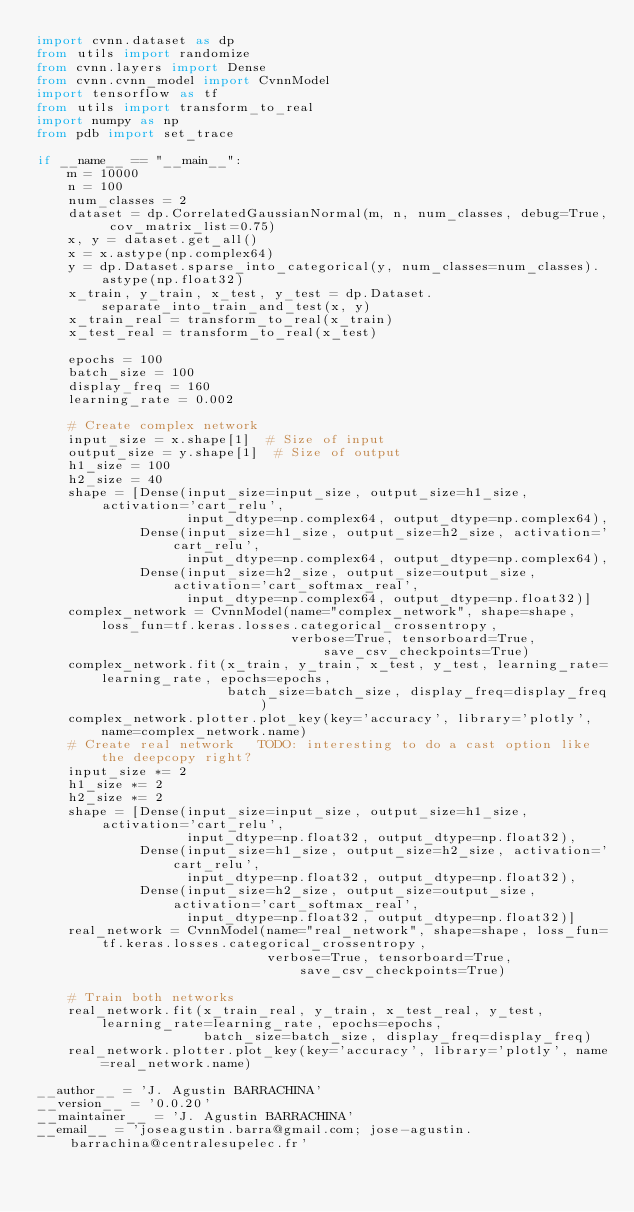Convert code to text. <code><loc_0><loc_0><loc_500><loc_500><_Python_>import cvnn.dataset as dp
from utils import randomize
from cvnn.layers import Dense
from cvnn.cvnn_model import CvnnModel
import tensorflow as tf
from utils import transform_to_real
import numpy as np
from pdb import set_trace

if __name__ == "__main__":
    m = 10000
    n = 100
    num_classes = 2
    dataset = dp.CorrelatedGaussianNormal(m, n, num_classes, debug=True, cov_matrix_list=0.75)
    x, y = dataset.get_all()
    x = x.astype(np.complex64)
    y = dp.Dataset.sparse_into_categorical(y, num_classes=num_classes).astype(np.float32)
    x_train, y_train, x_test, y_test = dp.Dataset.separate_into_train_and_test(x, y)
    x_train_real = transform_to_real(x_train)
    x_test_real = transform_to_real(x_test)

    epochs = 100
    batch_size = 100
    display_freq = 160
    learning_rate = 0.002

    # Create complex network
    input_size = x.shape[1]  # Size of input
    output_size = y.shape[1]  # Size of output
    h1_size = 100
    h2_size = 40
    shape = [Dense(input_size=input_size, output_size=h1_size, activation='cart_relu',
                   input_dtype=np.complex64, output_dtype=np.complex64),
             Dense(input_size=h1_size, output_size=h2_size, activation='cart_relu',
                   input_dtype=np.complex64, output_dtype=np.complex64),
             Dense(input_size=h2_size, output_size=output_size, activation='cart_softmax_real',
                   input_dtype=np.complex64, output_dtype=np.float32)]
    complex_network = CvnnModel(name="complex_network", shape=shape, loss_fun=tf.keras.losses.categorical_crossentropy,
                                verbose=True, tensorboard=True, save_csv_checkpoints=True)
    complex_network.fit(x_train, y_train, x_test, y_test, learning_rate=learning_rate, epochs=epochs,
                        batch_size=batch_size, display_freq=display_freq)
    complex_network.plotter.plot_key(key='accuracy', library='plotly', name=complex_network.name)
    # Create real network   TODO: interesting to do a cast option like the deepcopy right?
    input_size *= 2
    h1_size *= 2
    h2_size *= 2
    shape = [Dense(input_size=input_size, output_size=h1_size, activation='cart_relu',
                   input_dtype=np.float32, output_dtype=np.float32),
             Dense(input_size=h1_size, output_size=h2_size, activation='cart_relu',
                   input_dtype=np.float32, output_dtype=np.float32),
             Dense(input_size=h2_size, output_size=output_size, activation='cart_softmax_real',
                   input_dtype=np.float32, output_dtype=np.float32)]
    real_network = CvnnModel(name="real_network", shape=shape, loss_fun=tf.keras.losses.categorical_crossentropy,
                             verbose=True, tensorboard=True, save_csv_checkpoints=True)

    # Train both networks
    real_network.fit(x_train_real, y_train, x_test_real, y_test, learning_rate=learning_rate, epochs=epochs,
                     batch_size=batch_size, display_freq=display_freq)
    real_network.plotter.plot_key(key='accuracy', library='plotly', name=real_network.name)

__author__ = 'J. Agustin BARRACHINA'
__version__ = '0.0.20'
__maintainer__ = 'J. Agustin BARRACHINA'
__email__ = 'joseagustin.barra@gmail.com; jose-agustin.barrachina@centralesupelec.fr'
</code> 